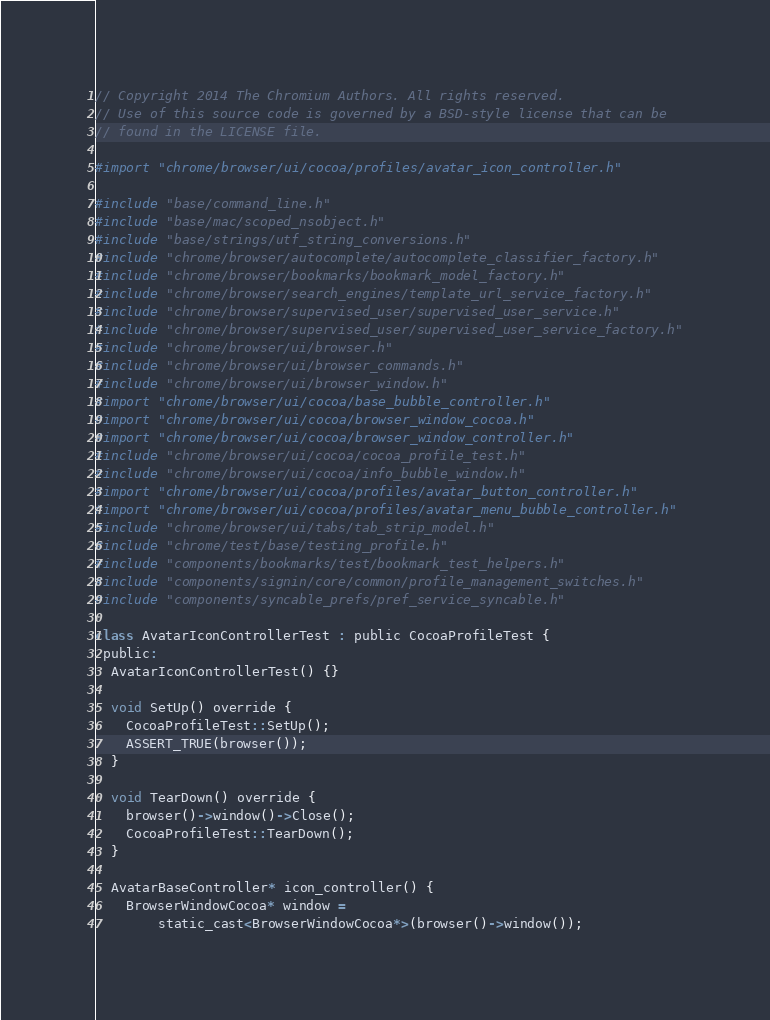Convert code to text. <code><loc_0><loc_0><loc_500><loc_500><_ObjectiveC_>// Copyright 2014 The Chromium Authors. All rights reserved.
// Use of this source code is governed by a BSD-style license that can be
// found in the LICENSE file.

#import "chrome/browser/ui/cocoa/profiles/avatar_icon_controller.h"

#include "base/command_line.h"
#include "base/mac/scoped_nsobject.h"
#include "base/strings/utf_string_conversions.h"
#include "chrome/browser/autocomplete/autocomplete_classifier_factory.h"
#include "chrome/browser/bookmarks/bookmark_model_factory.h"
#include "chrome/browser/search_engines/template_url_service_factory.h"
#include "chrome/browser/supervised_user/supervised_user_service.h"
#include "chrome/browser/supervised_user/supervised_user_service_factory.h"
#include "chrome/browser/ui/browser.h"
#include "chrome/browser/ui/browser_commands.h"
#include "chrome/browser/ui/browser_window.h"
#import "chrome/browser/ui/cocoa/base_bubble_controller.h"
#import "chrome/browser/ui/cocoa/browser_window_cocoa.h"
#import "chrome/browser/ui/cocoa/browser_window_controller.h"
#include "chrome/browser/ui/cocoa/cocoa_profile_test.h"
#include "chrome/browser/ui/cocoa/info_bubble_window.h"
#import "chrome/browser/ui/cocoa/profiles/avatar_button_controller.h"
#import "chrome/browser/ui/cocoa/profiles/avatar_menu_bubble_controller.h"
#include "chrome/browser/ui/tabs/tab_strip_model.h"
#include "chrome/test/base/testing_profile.h"
#include "components/bookmarks/test/bookmark_test_helpers.h"
#include "components/signin/core/common/profile_management_switches.h"
#include "components/syncable_prefs/pref_service_syncable.h"

class AvatarIconControllerTest : public CocoaProfileTest {
 public:
  AvatarIconControllerTest() {}

  void SetUp() override {
    CocoaProfileTest::SetUp();
    ASSERT_TRUE(browser());
  }

  void TearDown() override {
    browser()->window()->Close();
    CocoaProfileTest::TearDown();
  }

  AvatarBaseController* icon_controller() {
    BrowserWindowCocoa* window =
        static_cast<BrowserWindowCocoa*>(browser()->window());</code> 